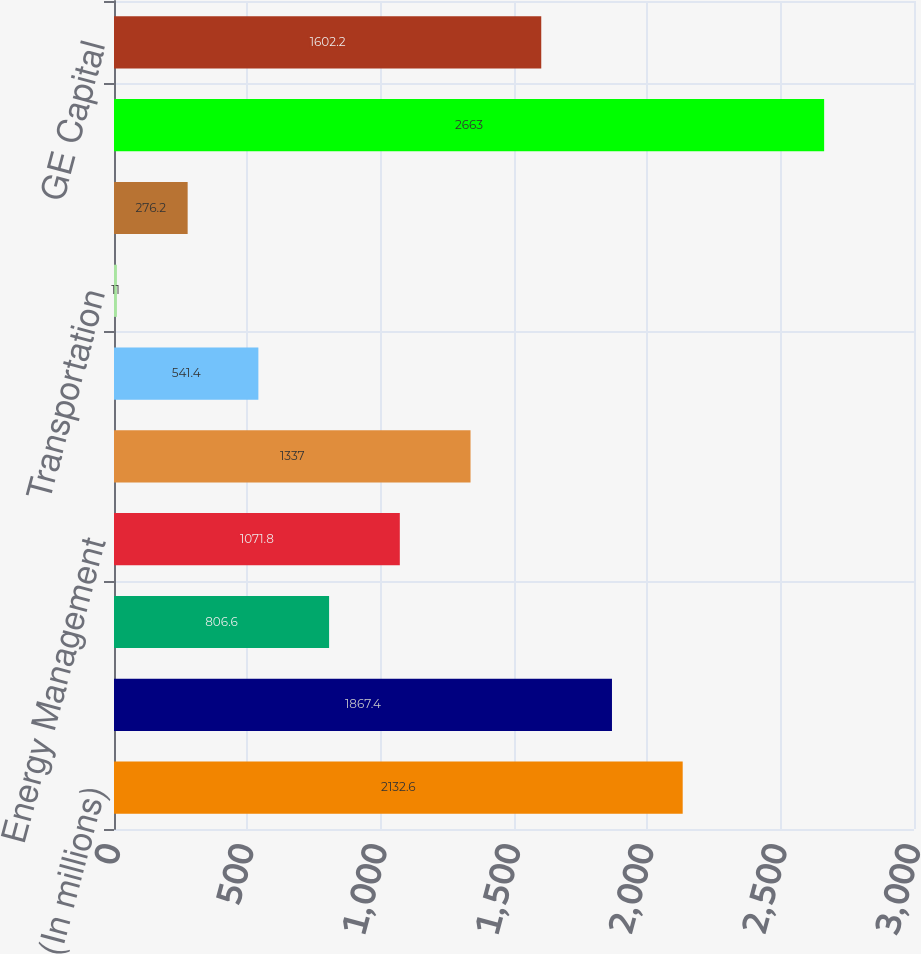Convert chart. <chart><loc_0><loc_0><loc_500><loc_500><bar_chart><fcel>(In millions)<fcel>Power & Water<fcel>Oil & Gas<fcel>Energy Management<fcel>Aviation<fcel>Healthcare<fcel>Transportation<fcel>Appliances & Lighting<fcel>Total industrial<fcel>GE Capital<nl><fcel>2132.6<fcel>1867.4<fcel>806.6<fcel>1071.8<fcel>1337<fcel>541.4<fcel>11<fcel>276.2<fcel>2663<fcel>1602.2<nl></chart> 